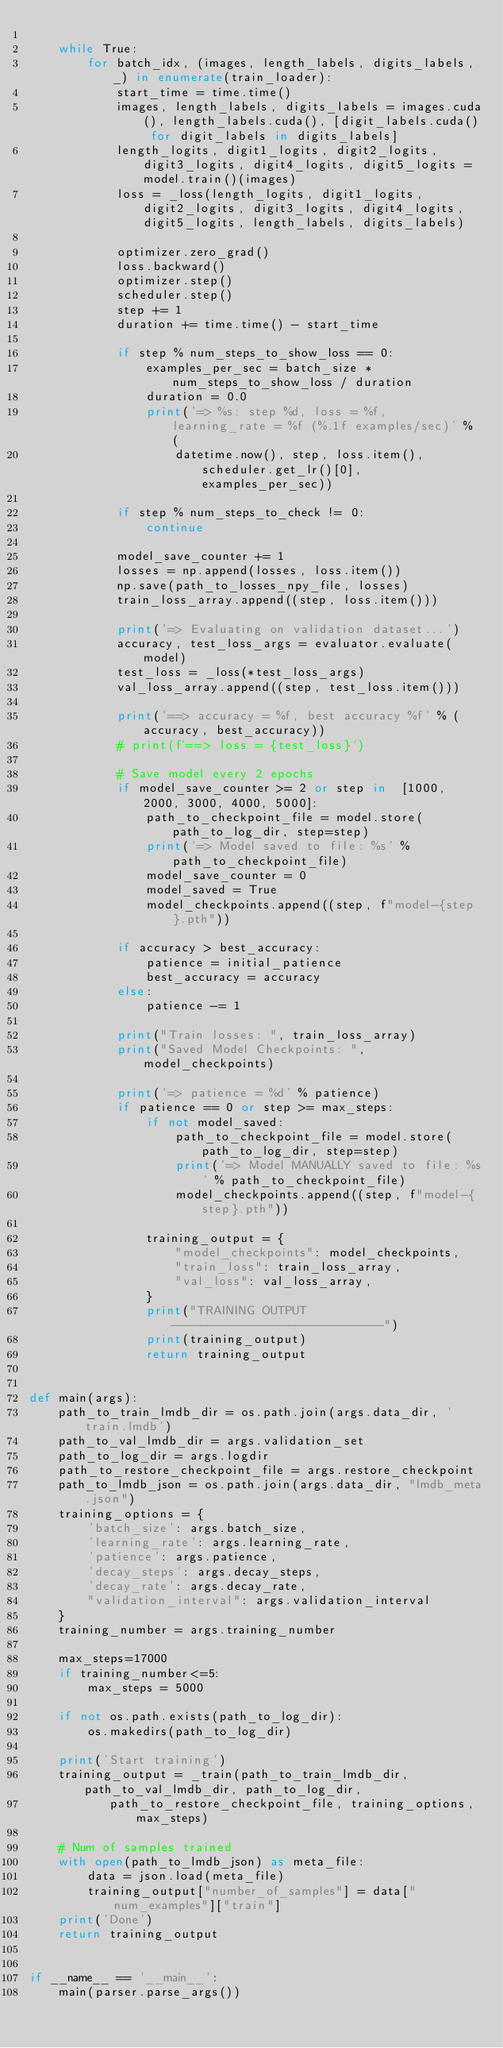Convert code to text. <code><loc_0><loc_0><loc_500><loc_500><_Python_>
    while True:
        for batch_idx, (images, length_labels, digits_labels, _) in enumerate(train_loader):
            start_time = time.time()
            images, length_labels, digits_labels = images.cuda(), length_labels.cuda(), [digit_labels.cuda() for digit_labels in digits_labels]
            length_logits, digit1_logits, digit2_logits, digit3_logits, digit4_logits, digit5_logits = model.train()(images)
            loss = _loss(length_logits, digit1_logits, digit2_logits, digit3_logits, digit4_logits, digit5_logits, length_labels, digits_labels)

            optimizer.zero_grad()
            loss.backward()
            optimizer.step()
            scheduler.step()
            step += 1
            duration += time.time() - start_time

            if step % num_steps_to_show_loss == 0:
                examples_per_sec = batch_size * num_steps_to_show_loss / duration
                duration = 0.0
                print('=> %s: step %d, loss = %f, learning_rate = %f (%.1f examples/sec)' % (
                    datetime.now(), step, loss.item(), scheduler.get_lr()[0], examples_per_sec))

            if step % num_steps_to_check != 0:
                continue

            model_save_counter += 1
            losses = np.append(losses, loss.item())
            np.save(path_to_losses_npy_file, losses)
            train_loss_array.append((step, loss.item()))

            print('=> Evaluating on validation dataset...')
            accuracy, test_loss_args = evaluator.evaluate(model)
            test_loss = _loss(*test_loss_args)
            val_loss_array.append((step, test_loss.item()))

            print('==> accuracy = %f, best accuracy %f' % (accuracy, best_accuracy))
            # print(f'==> loss = {test_loss}')

            # Save model every 2 epochs
            if model_save_counter >= 2 or step in  [1000, 2000, 3000, 4000, 5000]:
                path_to_checkpoint_file = model.store(path_to_log_dir, step=step)
                print('=> Model saved to file: %s' % path_to_checkpoint_file)
                model_save_counter = 0
                model_saved = True
                model_checkpoints.append((step, f"model-{step}.pth"))

            if accuracy > best_accuracy:
                patience = initial_patience
                best_accuracy = accuracy
            else:
                patience -= 1

            print("Train losses: ", train_loss_array)
            print("Saved Model Checkpoints: ", model_checkpoints)

            print('=> patience = %d' % patience)
            if patience == 0 or step >= max_steps:
                if not model_saved:
                    path_to_checkpoint_file = model.store(path_to_log_dir, step=step)
                    print('=> Model MANUALLY saved to file: %s' % path_to_checkpoint_file)
                    model_checkpoints.append((step, f"model-{step}.pth"))

                training_output = {
                    "model_checkpoints": model_checkpoints,
                    "train_loss": train_loss_array,
                    "val_loss": val_loss_array,
                }
                print("TRAINING OUTPUT -----------------------------")
                print(training_output)
                return training_output


def main(args):
    path_to_train_lmdb_dir = os.path.join(args.data_dir, 'train.lmdb')
    path_to_val_lmdb_dir = args.validation_set
    path_to_log_dir = args.logdir
    path_to_restore_checkpoint_file = args.restore_checkpoint
    path_to_lmdb_json = os.path.join(args.data_dir, "lmdb_meta.json")
    training_options = {
        'batch_size': args.batch_size,
        'learning_rate': args.learning_rate,
        'patience': args.patience,
        'decay_steps': args.decay_steps,
        'decay_rate': args.decay_rate,
        "validation_interval": args.validation_interval
    }
    training_number = args.training_number

    max_steps=17000
    if training_number<=5:
        max_steps = 5000

    if not os.path.exists(path_to_log_dir):
        os.makedirs(path_to_log_dir)

    print('Start training')
    training_output = _train(path_to_train_lmdb_dir, path_to_val_lmdb_dir, path_to_log_dir,
           path_to_restore_checkpoint_file, training_options, max_steps)

    # Num of samples trained
    with open(path_to_lmdb_json) as meta_file:
        data = json.load(meta_file)
        training_output["number_of_samples"] = data["num_examples"]["train"]
    print('Done')
    return training_output


if __name__ == '__main__':
    main(parser.parse_args())
</code> 